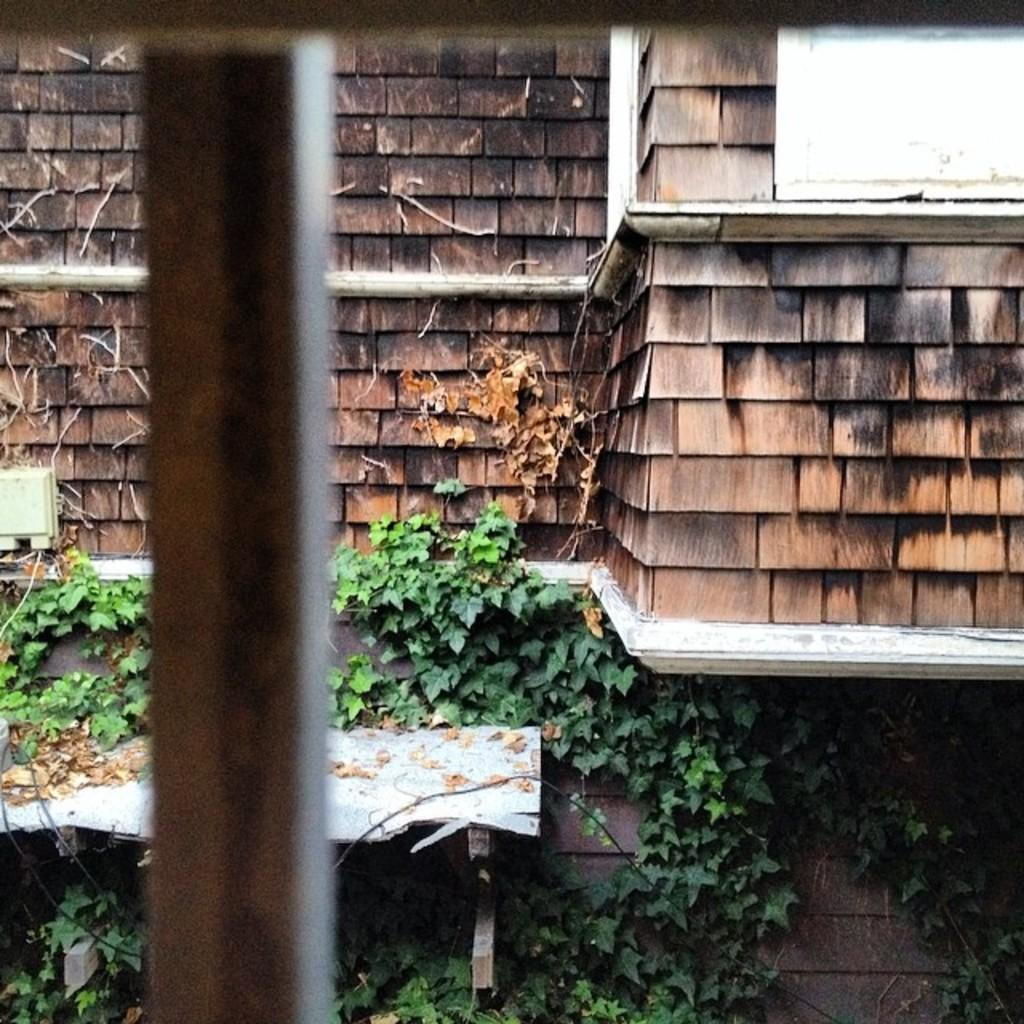What type of structure is visible in the picture? There is a building in the picture. What material is the building made of? The building is made up of brown colored bricks. What type of vegetation can be seen at the bottom of the picture? Creepers are present at the bottom of the picture. What object is located on the left side of the picture? There is an iron pole on the left side of the picture. What arithmetic problem is being solved on the building's wall in the image? There is no arithmetic problem visible on the building's wall in the image. What type of flower is growing on the iron pole in the image? There are no flowers present on the iron pole in the image. 